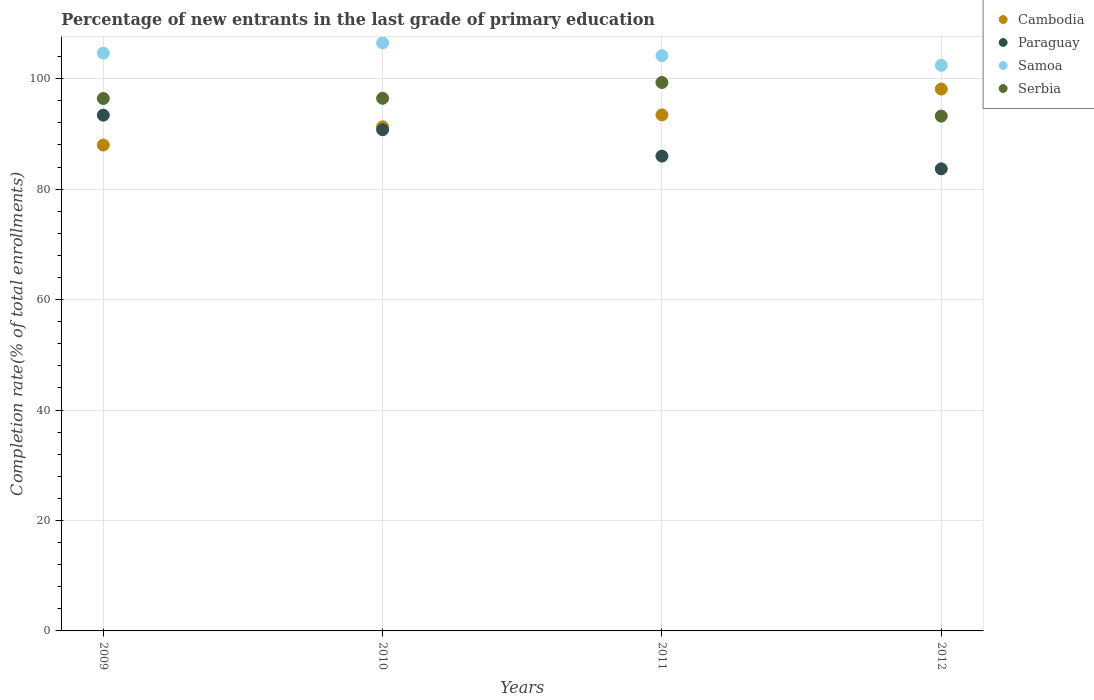Is the number of dotlines equal to the number of legend labels?
Offer a very short reply. Yes. What is the percentage of new entrants in Serbia in 2010?
Ensure brevity in your answer.  96.45. Across all years, what is the maximum percentage of new entrants in Paraguay?
Give a very brief answer. 93.4. Across all years, what is the minimum percentage of new entrants in Samoa?
Offer a very short reply. 102.41. In which year was the percentage of new entrants in Cambodia minimum?
Offer a terse response. 2009. What is the total percentage of new entrants in Samoa in the graph?
Keep it short and to the point. 417.69. What is the difference between the percentage of new entrants in Cambodia in 2011 and that in 2012?
Make the answer very short. -4.68. What is the difference between the percentage of new entrants in Samoa in 2011 and the percentage of new entrants in Cambodia in 2010?
Keep it short and to the point. 12.89. What is the average percentage of new entrants in Serbia per year?
Your response must be concise. 96.35. In the year 2011, what is the difference between the percentage of new entrants in Cambodia and percentage of new entrants in Serbia?
Provide a succinct answer. -5.87. In how many years, is the percentage of new entrants in Paraguay greater than 68 %?
Your answer should be compact. 4. What is the ratio of the percentage of new entrants in Cambodia in 2009 to that in 2010?
Keep it short and to the point. 0.96. Is the difference between the percentage of new entrants in Cambodia in 2011 and 2012 greater than the difference between the percentage of new entrants in Serbia in 2011 and 2012?
Keep it short and to the point. No. What is the difference between the highest and the second highest percentage of new entrants in Paraguay?
Your answer should be very brief. 2.64. What is the difference between the highest and the lowest percentage of new entrants in Cambodia?
Keep it short and to the point. 10.14. In how many years, is the percentage of new entrants in Cambodia greater than the average percentage of new entrants in Cambodia taken over all years?
Your answer should be very brief. 2. Is it the case that in every year, the sum of the percentage of new entrants in Paraguay and percentage of new entrants in Samoa  is greater than the sum of percentage of new entrants in Cambodia and percentage of new entrants in Serbia?
Ensure brevity in your answer.  No. Is the percentage of new entrants in Serbia strictly greater than the percentage of new entrants in Samoa over the years?
Provide a succinct answer. No. Is the percentage of new entrants in Cambodia strictly less than the percentage of new entrants in Samoa over the years?
Ensure brevity in your answer.  Yes. How many dotlines are there?
Your response must be concise. 4. What is the difference between two consecutive major ticks on the Y-axis?
Offer a very short reply. 20. Are the values on the major ticks of Y-axis written in scientific E-notation?
Keep it short and to the point. No. Where does the legend appear in the graph?
Offer a very short reply. Top right. How are the legend labels stacked?
Give a very brief answer. Vertical. What is the title of the graph?
Your answer should be very brief. Percentage of new entrants in the last grade of primary education. Does "Korea (Democratic)" appear as one of the legend labels in the graph?
Ensure brevity in your answer.  No. What is the label or title of the Y-axis?
Offer a terse response. Completion rate(% of total enrollments). What is the Completion rate(% of total enrollments) in Cambodia in 2009?
Give a very brief answer. 87.98. What is the Completion rate(% of total enrollments) of Paraguay in 2009?
Keep it short and to the point. 93.4. What is the Completion rate(% of total enrollments) of Samoa in 2009?
Keep it short and to the point. 104.62. What is the Completion rate(% of total enrollments) of Serbia in 2009?
Make the answer very short. 96.42. What is the Completion rate(% of total enrollments) of Cambodia in 2010?
Make the answer very short. 91.28. What is the Completion rate(% of total enrollments) of Paraguay in 2010?
Your response must be concise. 90.76. What is the Completion rate(% of total enrollments) in Samoa in 2010?
Give a very brief answer. 106.49. What is the Completion rate(% of total enrollments) of Serbia in 2010?
Offer a very short reply. 96.45. What is the Completion rate(% of total enrollments) in Cambodia in 2011?
Provide a succinct answer. 93.44. What is the Completion rate(% of total enrollments) of Paraguay in 2011?
Your answer should be compact. 85.98. What is the Completion rate(% of total enrollments) of Samoa in 2011?
Your answer should be very brief. 104.17. What is the Completion rate(% of total enrollments) in Serbia in 2011?
Your response must be concise. 99.31. What is the Completion rate(% of total enrollments) of Cambodia in 2012?
Keep it short and to the point. 98.13. What is the Completion rate(% of total enrollments) in Paraguay in 2012?
Provide a succinct answer. 83.68. What is the Completion rate(% of total enrollments) of Samoa in 2012?
Your answer should be compact. 102.41. What is the Completion rate(% of total enrollments) in Serbia in 2012?
Ensure brevity in your answer.  93.23. Across all years, what is the maximum Completion rate(% of total enrollments) in Cambodia?
Provide a short and direct response. 98.13. Across all years, what is the maximum Completion rate(% of total enrollments) in Paraguay?
Give a very brief answer. 93.4. Across all years, what is the maximum Completion rate(% of total enrollments) in Samoa?
Keep it short and to the point. 106.49. Across all years, what is the maximum Completion rate(% of total enrollments) in Serbia?
Your answer should be very brief. 99.31. Across all years, what is the minimum Completion rate(% of total enrollments) in Cambodia?
Your response must be concise. 87.98. Across all years, what is the minimum Completion rate(% of total enrollments) of Paraguay?
Offer a very short reply. 83.68. Across all years, what is the minimum Completion rate(% of total enrollments) in Samoa?
Make the answer very short. 102.41. Across all years, what is the minimum Completion rate(% of total enrollments) of Serbia?
Provide a succinct answer. 93.23. What is the total Completion rate(% of total enrollments) in Cambodia in the graph?
Ensure brevity in your answer.  370.83. What is the total Completion rate(% of total enrollments) in Paraguay in the graph?
Ensure brevity in your answer.  353.81. What is the total Completion rate(% of total enrollments) in Samoa in the graph?
Ensure brevity in your answer.  417.69. What is the total Completion rate(% of total enrollments) in Serbia in the graph?
Your answer should be very brief. 385.4. What is the difference between the Completion rate(% of total enrollments) of Cambodia in 2009 and that in 2010?
Your answer should be very brief. -3.29. What is the difference between the Completion rate(% of total enrollments) in Paraguay in 2009 and that in 2010?
Make the answer very short. 2.64. What is the difference between the Completion rate(% of total enrollments) of Samoa in 2009 and that in 2010?
Ensure brevity in your answer.  -1.87. What is the difference between the Completion rate(% of total enrollments) in Serbia in 2009 and that in 2010?
Keep it short and to the point. -0.03. What is the difference between the Completion rate(% of total enrollments) in Cambodia in 2009 and that in 2011?
Provide a succinct answer. -5.46. What is the difference between the Completion rate(% of total enrollments) of Paraguay in 2009 and that in 2011?
Provide a succinct answer. 7.42. What is the difference between the Completion rate(% of total enrollments) in Samoa in 2009 and that in 2011?
Make the answer very short. 0.45. What is the difference between the Completion rate(% of total enrollments) of Serbia in 2009 and that in 2011?
Keep it short and to the point. -2.89. What is the difference between the Completion rate(% of total enrollments) of Cambodia in 2009 and that in 2012?
Offer a very short reply. -10.14. What is the difference between the Completion rate(% of total enrollments) in Paraguay in 2009 and that in 2012?
Your answer should be very brief. 9.72. What is the difference between the Completion rate(% of total enrollments) of Samoa in 2009 and that in 2012?
Your answer should be very brief. 2.21. What is the difference between the Completion rate(% of total enrollments) in Serbia in 2009 and that in 2012?
Give a very brief answer. 3.19. What is the difference between the Completion rate(% of total enrollments) of Cambodia in 2010 and that in 2011?
Keep it short and to the point. -2.16. What is the difference between the Completion rate(% of total enrollments) in Paraguay in 2010 and that in 2011?
Offer a very short reply. 4.78. What is the difference between the Completion rate(% of total enrollments) of Samoa in 2010 and that in 2011?
Keep it short and to the point. 2.32. What is the difference between the Completion rate(% of total enrollments) of Serbia in 2010 and that in 2011?
Offer a very short reply. -2.86. What is the difference between the Completion rate(% of total enrollments) in Cambodia in 2010 and that in 2012?
Give a very brief answer. -6.85. What is the difference between the Completion rate(% of total enrollments) in Paraguay in 2010 and that in 2012?
Your response must be concise. 7.08. What is the difference between the Completion rate(% of total enrollments) in Samoa in 2010 and that in 2012?
Make the answer very short. 4.07. What is the difference between the Completion rate(% of total enrollments) of Serbia in 2010 and that in 2012?
Make the answer very short. 3.22. What is the difference between the Completion rate(% of total enrollments) of Cambodia in 2011 and that in 2012?
Your response must be concise. -4.68. What is the difference between the Completion rate(% of total enrollments) in Paraguay in 2011 and that in 2012?
Make the answer very short. 2.3. What is the difference between the Completion rate(% of total enrollments) of Samoa in 2011 and that in 2012?
Make the answer very short. 1.76. What is the difference between the Completion rate(% of total enrollments) in Serbia in 2011 and that in 2012?
Provide a succinct answer. 6.08. What is the difference between the Completion rate(% of total enrollments) in Cambodia in 2009 and the Completion rate(% of total enrollments) in Paraguay in 2010?
Provide a short and direct response. -2.77. What is the difference between the Completion rate(% of total enrollments) in Cambodia in 2009 and the Completion rate(% of total enrollments) in Samoa in 2010?
Offer a very short reply. -18.5. What is the difference between the Completion rate(% of total enrollments) in Cambodia in 2009 and the Completion rate(% of total enrollments) in Serbia in 2010?
Make the answer very short. -8.46. What is the difference between the Completion rate(% of total enrollments) in Paraguay in 2009 and the Completion rate(% of total enrollments) in Samoa in 2010?
Provide a succinct answer. -13.09. What is the difference between the Completion rate(% of total enrollments) of Paraguay in 2009 and the Completion rate(% of total enrollments) of Serbia in 2010?
Offer a terse response. -3.05. What is the difference between the Completion rate(% of total enrollments) in Samoa in 2009 and the Completion rate(% of total enrollments) in Serbia in 2010?
Ensure brevity in your answer.  8.17. What is the difference between the Completion rate(% of total enrollments) of Cambodia in 2009 and the Completion rate(% of total enrollments) of Paraguay in 2011?
Your answer should be compact. 2. What is the difference between the Completion rate(% of total enrollments) of Cambodia in 2009 and the Completion rate(% of total enrollments) of Samoa in 2011?
Offer a terse response. -16.18. What is the difference between the Completion rate(% of total enrollments) in Cambodia in 2009 and the Completion rate(% of total enrollments) in Serbia in 2011?
Provide a succinct answer. -11.32. What is the difference between the Completion rate(% of total enrollments) of Paraguay in 2009 and the Completion rate(% of total enrollments) of Samoa in 2011?
Ensure brevity in your answer.  -10.77. What is the difference between the Completion rate(% of total enrollments) in Paraguay in 2009 and the Completion rate(% of total enrollments) in Serbia in 2011?
Keep it short and to the point. -5.91. What is the difference between the Completion rate(% of total enrollments) in Samoa in 2009 and the Completion rate(% of total enrollments) in Serbia in 2011?
Make the answer very short. 5.31. What is the difference between the Completion rate(% of total enrollments) of Cambodia in 2009 and the Completion rate(% of total enrollments) of Paraguay in 2012?
Provide a short and direct response. 4.31. What is the difference between the Completion rate(% of total enrollments) in Cambodia in 2009 and the Completion rate(% of total enrollments) in Samoa in 2012?
Give a very brief answer. -14.43. What is the difference between the Completion rate(% of total enrollments) in Cambodia in 2009 and the Completion rate(% of total enrollments) in Serbia in 2012?
Give a very brief answer. -5.24. What is the difference between the Completion rate(% of total enrollments) of Paraguay in 2009 and the Completion rate(% of total enrollments) of Samoa in 2012?
Offer a terse response. -9.01. What is the difference between the Completion rate(% of total enrollments) of Paraguay in 2009 and the Completion rate(% of total enrollments) of Serbia in 2012?
Your answer should be compact. 0.17. What is the difference between the Completion rate(% of total enrollments) in Samoa in 2009 and the Completion rate(% of total enrollments) in Serbia in 2012?
Your answer should be very brief. 11.39. What is the difference between the Completion rate(% of total enrollments) in Cambodia in 2010 and the Completion rate(% of total enrollments) in Paraguay in 2011?
Your answer should be compact. 5.3. What is the difference between the Completion rate(% of total enrollments) in Cambodia in 2010 and the Completion rate(% of total enrollments) in Samoa in 2011?
Provide a succinct answer. -12.89. What is the difference between the Completion rate(% of total enrollments) in Cambodia in 2010 and the Completion rate(% of total enrollments) in Serbia in 2011?
Make the answer very short. -8.03. What is the difference between the Completion rate(% of total enrollments) in Paraguay in 2010 and the Completion rate(% of total enrollments) in Samoa in 2011?
Your response must be concise. -13.41. What is the difference between the Completion rate(% of total enrollments) in Paraguay in 2010 and the Completion rate(% of total enrollments) in Serbia in 2011?
Give a very brief answer. -8.55. What is the difference between the Completion rate(% of total enrollments) of Samoa in 2010 and the Completion rate(% of total enrollments) of Serbia in 2011?
Keep it short and to the point. 7.18. What is the difference between the Completion rate(% of total enrollments) in Cambodia in 2010 and the Completion rate(% of total enrollments) in Paraguay in 2012?
Ensure brevity in your answer.  7.6. What is the difference between the Completion rate(% of total enrollments) of Cambodia in 2010 and the Completion rate(% of total enrollments) of Samoa in 2012?
Your answer should be compact. -11.13. What is the difference between the Completion rate(% of total enrollments) in Cambodia in 2010 and the Completion rate(% of total enrollments) in Serbia in 2012?
Ensure brevity in your answer.  -1.95. What is the difference between the Completion rate(% of total enrollments) in Paraguay in 2010 and the Completion rate(% of total enrollments) in Samoa in 2012?
Offer a terse response. -11.65. What is the difference between the Completion rate(% of total enrollments) of Paraguay in 2010 and the Completion rate(% of total enrollments) of Serbia in 2012?
Offer a very short reply. -2.47. What is the difference between the Completion rate(% of total enrollments) in Samoa in 2010 and the Completion rate(% of total enrollments) in Serbia in 2012?
Give a very brief answer. 13.26. What is the difference between the Completion rate(% of total enrollments) in Cambodia in 2011 and the Completion rate(% of total enrollments) in Paraguay in 2012?
Offer a very short reply. 9.76. What is the difference between the Completion rate(% of total enrollments) in Cambodia in 2011 and the Completion rate(% of total enrollments) in Samoa in 2012?
Provide a succinct answer. -8.97. What is the difference between the Completion rate(% of total enrollments) of Cambodia in 2011 and the Completion rate(% of total enrollments) of Serbia in 2012?
Make the answer very short. 0.22. What is the difference between the Completion rate(% of total enrollments) of Paraguay in 2011 and the Completion rate(% of total enrollments) of Samoa in 2012?
Provide a short and direct response. -16.43. What is the difference between the Completion rate(% of total enrollments) of Paraguay in 2011 and the Completion rate(% of total enrollments) of Serbia in 2012?
Offer a very short reply. -7.25. What is the difference between the Completion rate(% of total enrollments) in Samoa in 2011 and the Completion rate(% of total enrollments) in Serbia in 2012?
Your answer should be very brief. 10.94. What is the average Completion rate(% of total enrollments) in Cambodia per year?
Provide a succinct answer. 92.71. What is the average Completion rate(% of total enrollments) in Paraguay per year?
Make the answer very short. 88.45. What is the average Completion rate(% of total enrollments) of Samoa per year?
Offer a very short reply. 104.42. What is the average Completion rate(% of total enrollments) in Serbia per year?
Your answer should be compact. 96.35. In the year 2009, what is the difference between the Completion rate(% of total enrollments) of Cambodia and Completion rate(% of total enrollments) of Paraguay?
Make the answer very short. -5.41. In the year 2009, what is the difference between the Completion rate(% of total enrollments) of Cambodia and Completion rate(% of total enrollments) of Samoa?
Ensure brevity in your answer.  -16.64. In the year 2009, what is the difference between the Completion rate(% of total enrollments) of Cambodia and Completion rate(% of total enrollments) of Serbia?
Make the answer very short. -8.43. In the year 2009, what is the difference between the Completion rate(% of total enrollments) of Paraguay and Completion rate(% of total enrollments) of Samoa?
Your answer should be compact. -11.22. In the year 2009, what is the difference between the Completion rate(% of total enrollments) of Paraguay and Completion rate(% of total enrollments) of Serbia?
Your response must be concise. -3.02. In the year 2009, what is the difference between the Completion rate(% of total enrollments) of Samoa and Completion rate(% of total enrollments) of Serbia?
Give a very brief answer. 8.2. In the year 2010, what is the difference between the Completion rate(% of total enrollments) of Cambodia and Completion rate(% of total enrollments) of Paraguay?
Ensure brevity in your answer.  0.52. In the year 2010, what is the difference between the Completion rate(% of total enrollments) of Cambodia and Completion rate(% of total enrollments) of Samoa?
Give a very brief answer. -15.21. In the year 2010, what is the difference between the Completion rate(% of total enrollments) in Cambodia and Completion rate(% of total enrollments) in Serbia?
Offer a very short reply. -5.17. In the year 2010, what is the difference between the Completion rate(% of total enrollments) in Paraguay and Completion rate(% of total enrollments) in Samoa?
Offer a terse response. -15.73. In the year 2010, what is the difference between the Completion rate(% of total enrollments) in Paraguay and Completion rate(% of total enrollments) in Serbia?
Offer a very short reply. -5.69. In the year 2010, what is the difference between the Completion rate(% of total enrollments) in Samoa and Completion rate(% of total enrollments) in Serbia?
Give a very brief answer. 10.04. In the year 2011, what is the difference between the Completion rate(% of total enrollments) of Cambodia and Completion rate(% of total enrollments) of Paraguay?
Make the answer very short. 7.46. In the year 2011, what is the difference between the Completion rate(% of total enrollments) in Cambodia and Completion rate(% of total enrollments) in Samoa?
Offer a terse response. -10.73. In the year 2011, what is the difference between the Completion rate(% of total enrollments) of Cambodia and Completion rate(% of total enrollments) of Serbia?
Ensure brevity in your answer.  -5.87. In the year 2011, what is the difference between the Completion rate(% of total enrollments) of Paraguay and Completion rate(% of total enrollments) of Samoa?
Ensure brevity in your answer.  -18.19. In the year 2011, what is the difference between the Completion rate(% of total enrollments) of Paraguay and Completion rate(% of total enrollments) of Serbia?
Ensure brevity in your answer.  -13.33. In the year 2011, what is the difference between the Completion rate(% of total enrollments) in Samoa and Completion rate(% of total enrollments) in Serbia?
Keep it short and to the point. 4.86. In the year 2012, what is the difference between the Completion rate(% of total enrollments) in Cambodia and Completion rate(% of total enrollments) in Paraguay?
Offer a very short reply. 14.45. In the year 2012, what is the difference between the Completion rate(% of total enrollments) of Cambodia and Completion rate(% of total enrollments) of Samoa?
Make the answer very short. -4.29. In the year 2012, what is the difference between the Completion rate(% of total enrollments) in Cambodia and Completion rate(% of total enrollments) in Serbia?
Offer a terse response. 4.9. In the year 2012, what is the difference between the Completion rate(% of total enrollments) of Paraguay and Completion rate(% of total enrollments) of Samoa?
Your answer should be compact. -18.73. In the year 2012, what is the difference between the Completion rate(% of total enrollments) in Paraguay and Completion rate(% of total enrollments) in Serbia?
Give a very brief answer. -9.55. In the year 2012, what is the difference between the Completion rate(% of total enrollments) of Samoa and Completion rate(% of total enrollments) of Serbia?
Provide a succinct answer. 9.19. What is the ratio of the Completion rate(% of total enrollments) in Cambodia in 2009 to that in 2010?
Your answer should be compact. 0.96. What is the ratio of the Completion rate(% of total enrollments) in Paraguay in 2009 to that in 2010?
Ensure brevity in your answer.  1.03. What is the ratio of the Completion rate(% of total enrollments) of Samoa in 2009 to that in 2010?
Ensure brevity in your answer.  0.98. What is the ratio of the Completion rate(% of total enrollments) of Cambodia in 2009 to that in 2011?
Your response must be concise. 0.94. What is the ratio of the Completion rate(% of total enrollments) of Paraguay in 2009 to that in 2011?
Ensure brevity in your answer.  1.09. What is the ratio of the Completion rate(% of total enrollments) of Samoa in 2009 to that in 2011?
Keep it short and to the point. 1. What is the ratio of the Completion rate(% of total enrollments) of Serbia in 2009 to that in 2011?
Keep it short and to the point. 0.97. What is the ratio of the Completion rate(% of total enrollments) of Cambodia in 2009 to that in 2012?
Offer a terse response. 0.9. What is the ratio of the Completion rate(% of total enrollments) in Paraguay in 2009 to that in 2012?
Offer a very short reply. 1.12. What is the ratio of the Completion rate(% of total enrollments) in Samoa in 2009 to that in 2012?
Offer a very short reply. 1.02. What is the ratio of the Completion rate(% of total enrollments) of Serbia in 2009 to that in 2012?
Keep it short and to the point. 1.03. What is the ratio of the Completion rate(% of total enrollments) of Cambodia in 2010 to that in 2011?
Keep it short and to the point. 0.98. What is the ratio of the Completion rate(% of total enrollments) of Paraguay in 2010 to that in 2011?
Offer a very short reply. 1.06. What is the ratio of the Completion rate(% of total enrollments) of Samoa in 2010 to that in 2011?
Make the answer very short. 1.02. What is the ratio of the Completion rate(% of total enrollments) of Serbia in 2010 to that in 2011?
Make the answer very short. 0.97. What is the ratio of the Completion rate(% of total enrollments) of Cambodia in 2010 to that in 2012?
Give a very brief answer. 0.93. What is the ratio of the Completion rate(% of total enrollments) in Paraguay in 2010 to that in 2012?
Your answer should be very brief. 1.08. What is the ratio of the Completion rate(% of total enrollments) of Samoa in 2010 to that in 2012?
Ensure brevity in your answer.  1.04. What is the ratio of the Completion rate(% of total enrollments) in Serbia in 2010 to that in 2012?
Keep it short and to the point. 1.03. What is the ratio of the Completion rate(% of total enrollments) in Cambodia in 2011 to that in 2012?
Ensure brevity in your answer.  0.95. What is the ratio of the Completion rate(% of total enrollments) of Paraguay in 2011 to that in 2012?
Your answer should be very brief. 1.03. What is the ratio of the Completion rate(% of total enrollments) in Samoa in 2011 to that in 2012?
Offer a terse response. 1.02. What is the ratio of the Completion rate(% of total enrollments) in Serbia in 2011 to that in 2012?
Your answer should be compact. 1.07. What is the difference between the highest and the second highest Completion rate(% of total enrollments) in Cambodia?
Your answer should be compact. 4.68. What is the difference between the highest and the second highest Completion rate(% of total enrollments) in Paraguay?
Your response must be concise. 2.64. What is the difference between the highest and the second highest Completion rate(% of total enrollments) in Samoa?
Your answer should be compact. 1.87. What is the difference between the highest and the second highest Completion rate(% of total enrollments) of Serbia?
Your answer should be compact. 2.86. What is the difference between the highest and the lowest Completion rate(% of total enrollments) of Cambodia?
Keep it short and to the point. 10.14. What is the difference between the highest and the lowest Completion rate(% of total enrollments) of Paraguay?
Make the answer very short. 9.72. What is the difference between the highest and the lowest Completion rate(% of total enrollments) of Samoa?
Provide a short and direct response. 4.07. What is the difference between the highest and the lowest Completion rate(% of total enrollments) of Serbia?
Offer a very short reply. 6.08. 